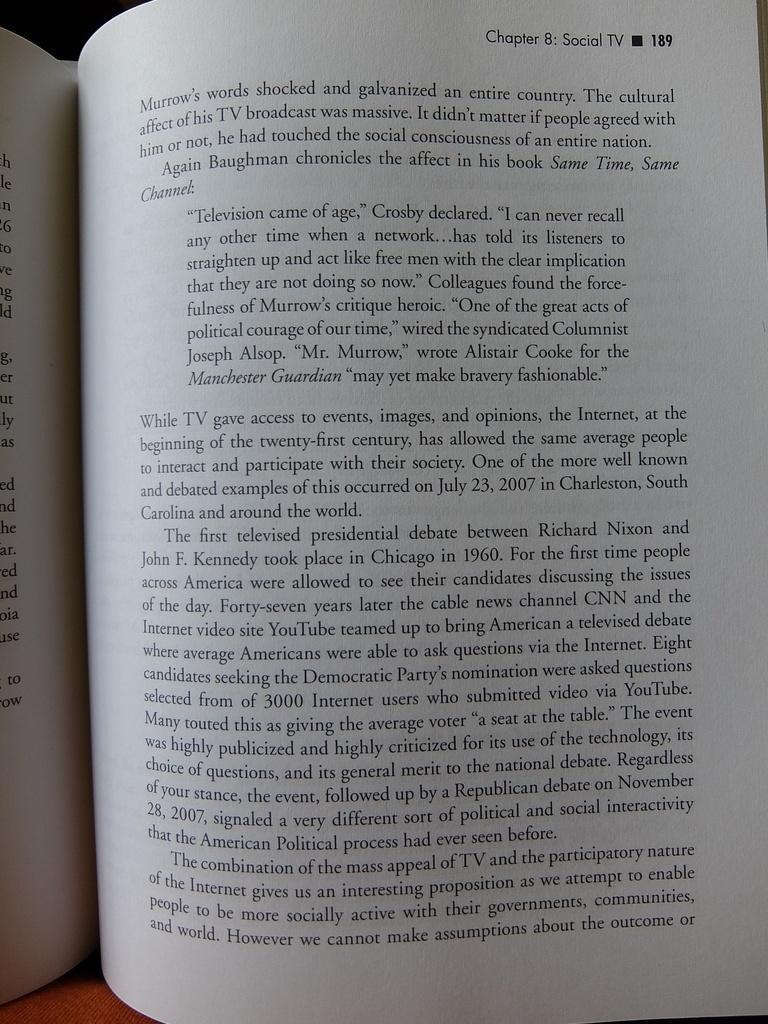In one or two sentences, can you explain what this image depicts? In this image we can see a book and some text. 